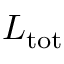Convert formula to latex. <formula><loc_0><loc_0><loc_500><loc_500>L _ { t o t }</formula> 